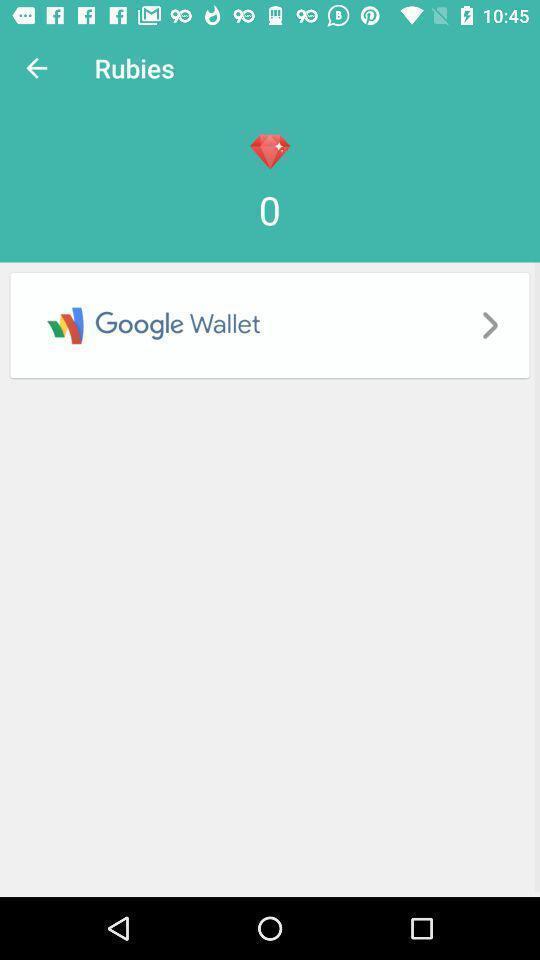Give me a summary of this screen capture. Page shows the social application. 